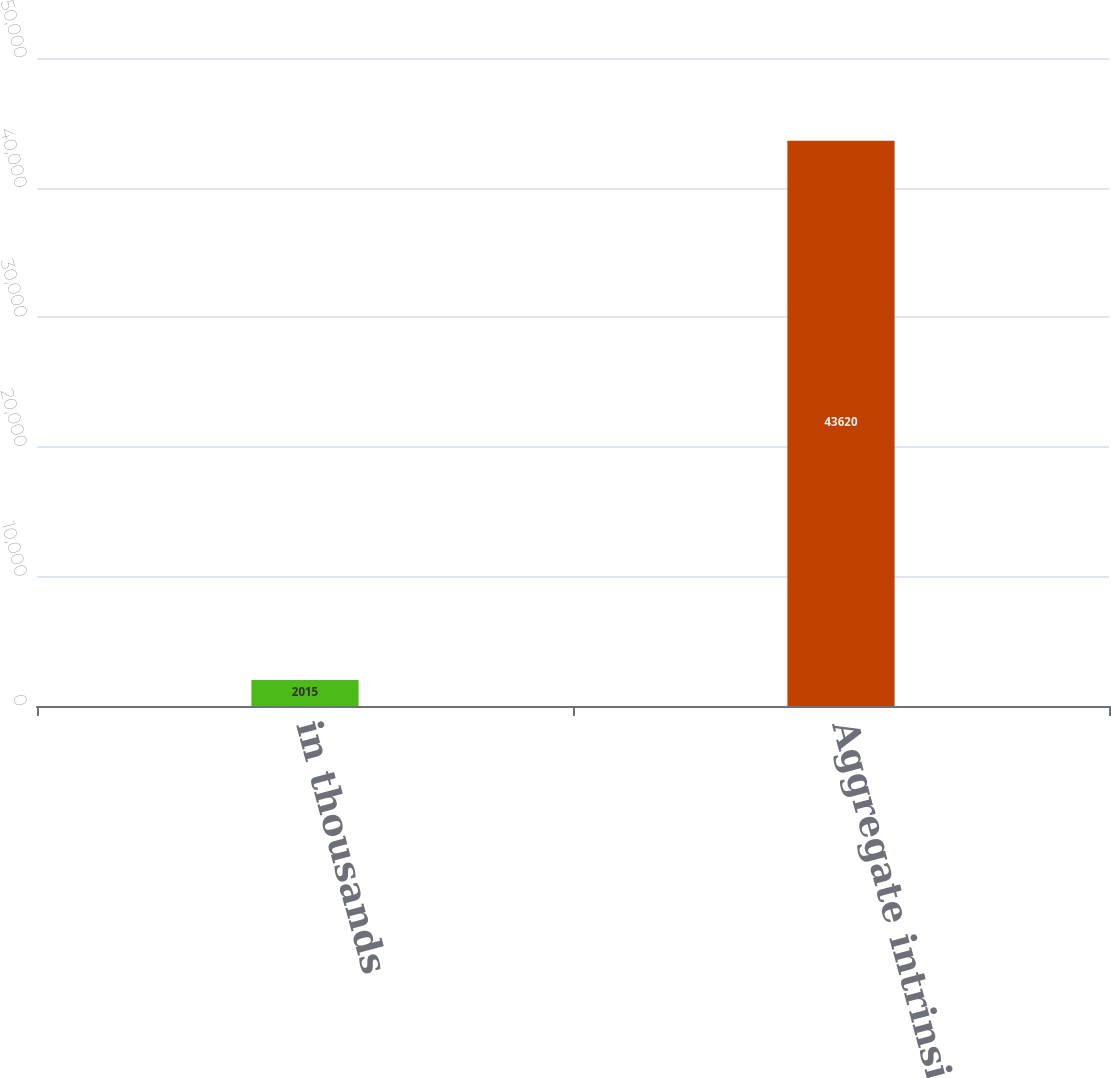Convert chart to OTSL. <chart><loc_0><loc_0><loc_500><loc_500><bar_chart><fcel>in thousands<fcel>Aggregate intrinsic value of<nl><fcel>2015<fcel>43620<nl></chart> 